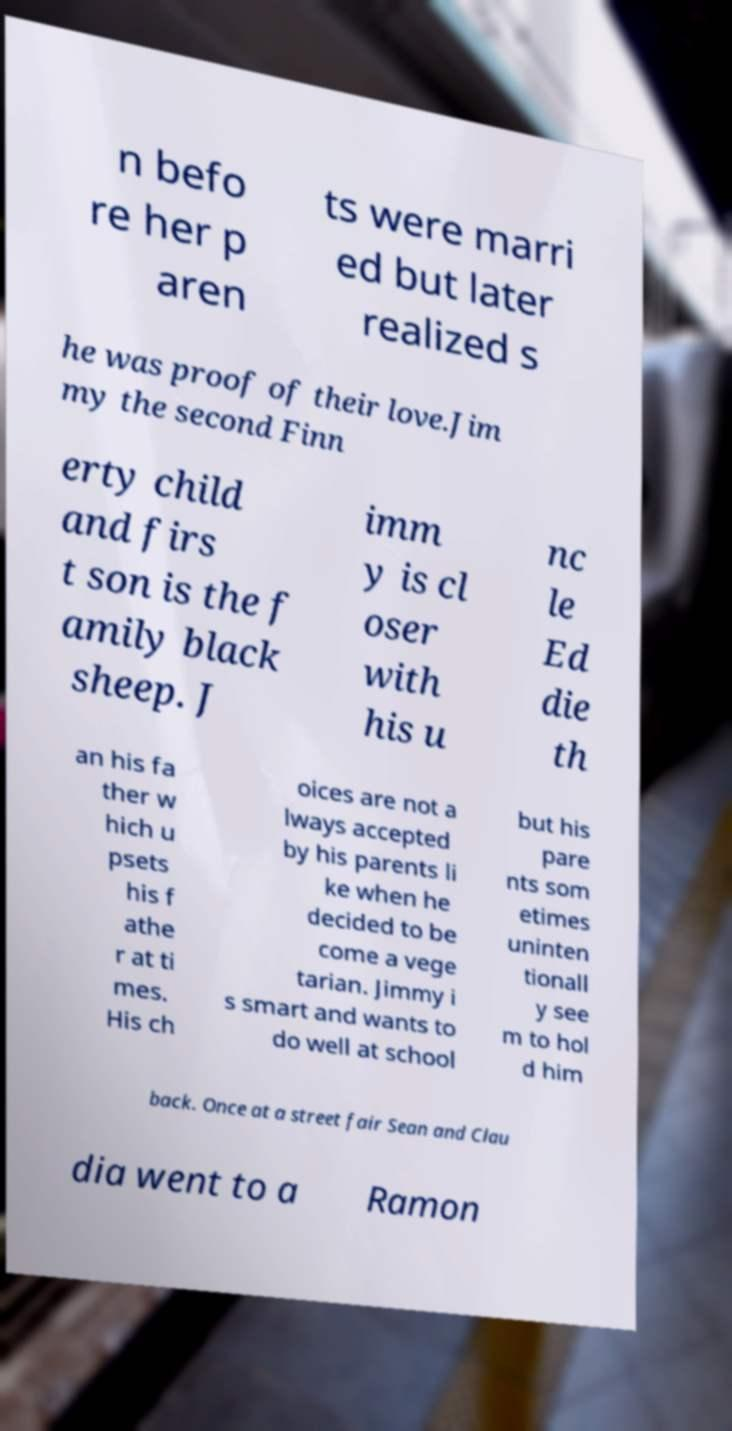Please identify and transcribe the text found in this image. n befo re her p aren ts were marri ed but later realized s he was proof of their love.Jim my the second Finn erty child and firs t son is the f amily black sheep. J imm y is cl oser with his u nc le Ed die th an his fa ther w hich u psets his f athe r at ti mes. His ch oices are not a lways accepted by his parents li ke when he decided to be come a vege tarian. Jimmy i s smart and wants to do well at school but his pare nts som etimes uninten tionall y see m to hol d him back. Once at a street fair Sean and Clau dia went to a Ramon 